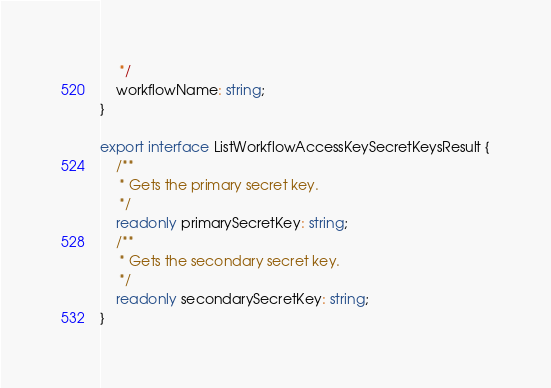Convert code to text. <code><loc_0><loc_0><loc_500><loc_500><_TypeScript_>     */
    workflowName: string;
}

export interface ListWorkflowAccessKeySecretKeysResult {
    /**
     * Gets the primary secret key.
     */
    readonly primarySecretKey: string;
    /**
     * Gets the secondary secret key.
     */
    readonly secondarySecretKey: string;
}
</code> 